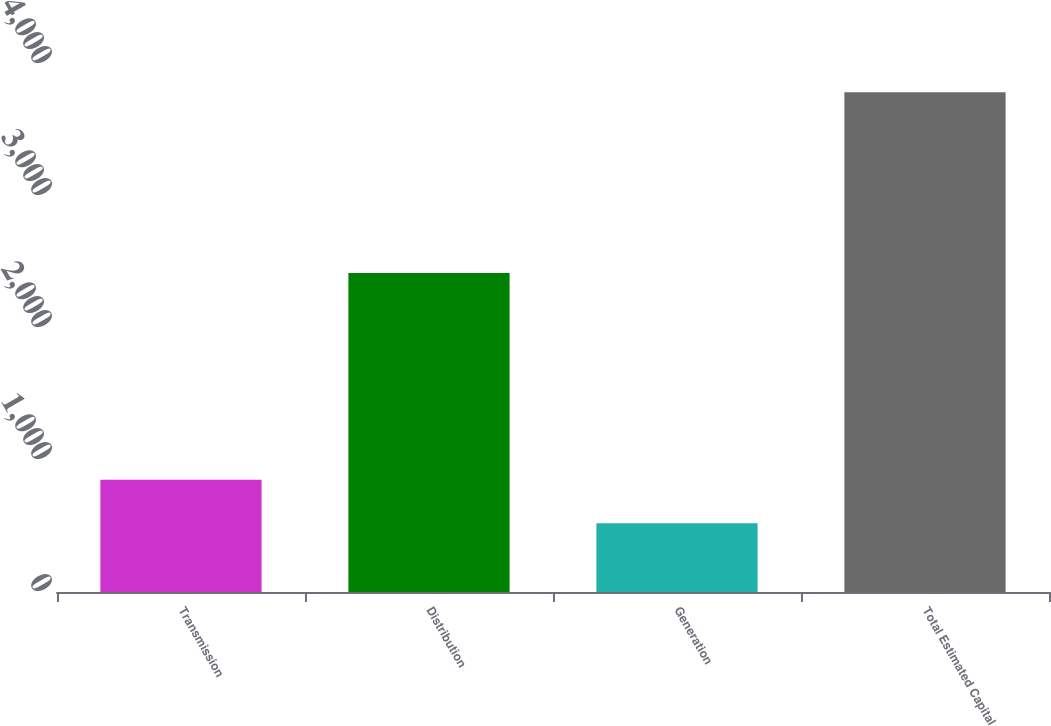<chart> <loc_0><loc_0><loc_500><loc_500><bar_chart><fcel>Transmission<fcel>Distribution<fcel>Generation<fcel>Total Estimated Capital<nl><fcel>850<fcel>2416<fcel>520<fcel>3786<nl></chart> 